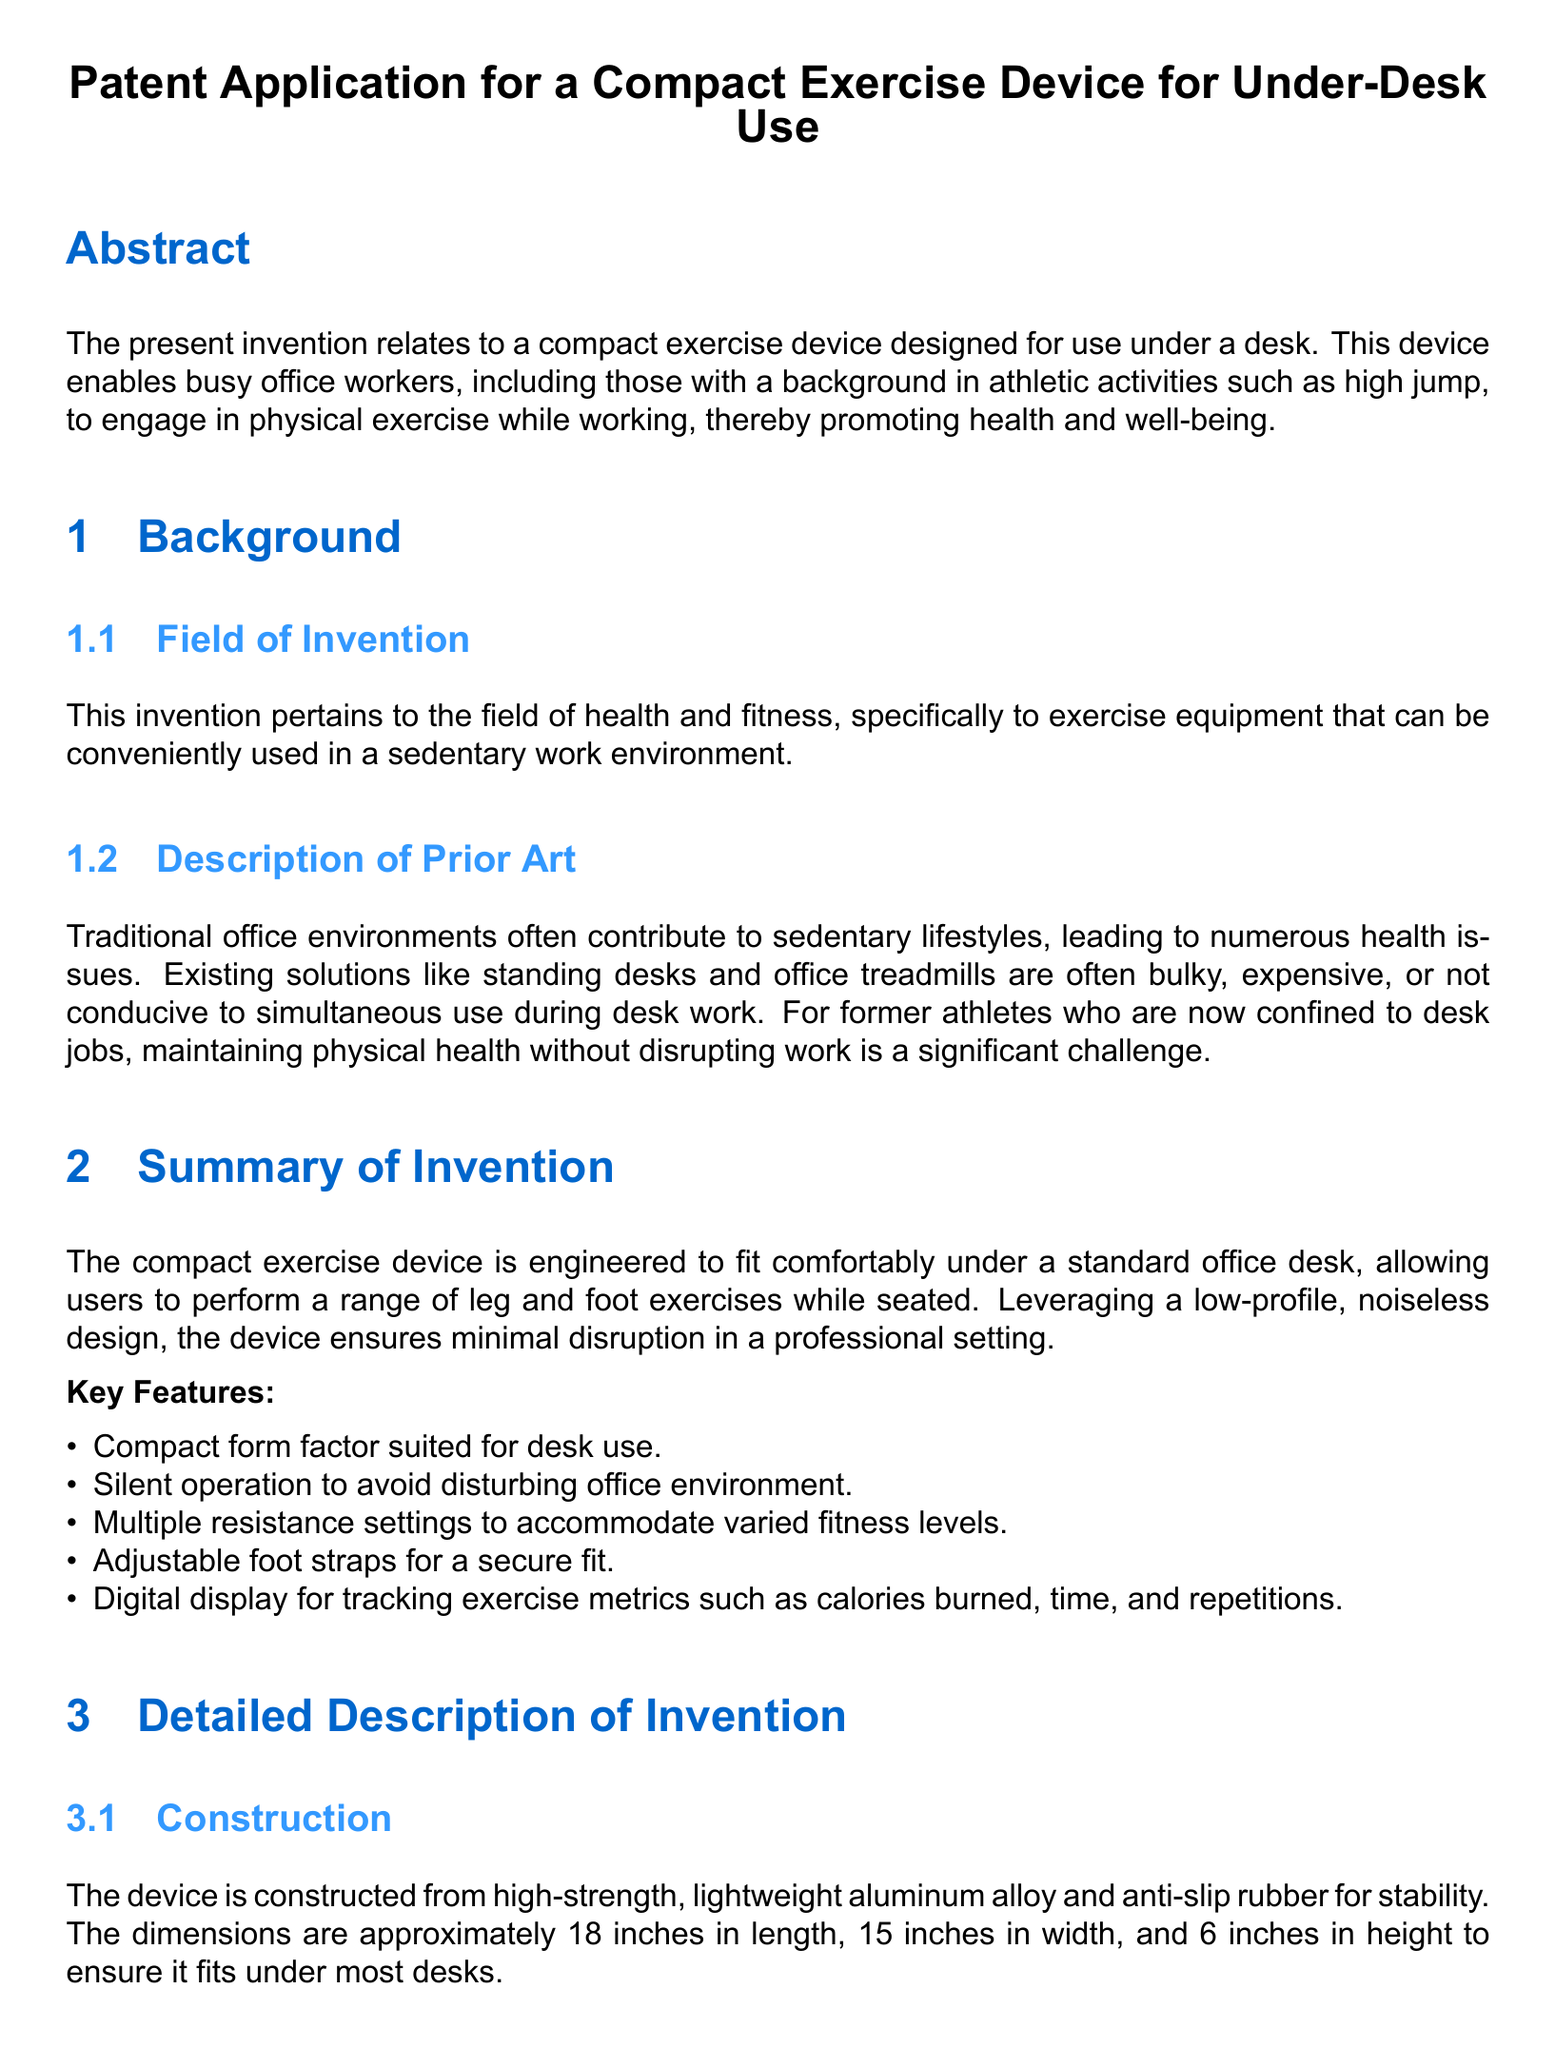What is the subject of the patent application? The patent application focuses on a device for exercise use while working at a desk.
Answer: Compact Exercise Device for Under-Desk Use What material is the device constructed from? The document specifies the material used for construction is high-strength, lightweight aluminum alloy and anti-slip rubber.
Answer: Aluminum alloy and anti-slip rubber What is the dimension of the device in height? The height of the device is specifically mentioned in the document.
Answer: 6 inches How many resistance settings does the device have? The document contains information about resistance settings available in the device, which is a feature for user adaptation.
Answer: Multiple resistance settings What is displayed on the digital screen of the device? The document notes the information tracked by the digital display, including various metrics.
Answer: Calories burned, time, and repetitions What type of resistance does the device utilize? The document describes the mechanism used for resistance in the exercise device.
Answer: Magnetic resistance What is the target user group for this device? The document outlines the target demographic benefiting from this invention, which includes athletes and professionals.
Answer: Busy office workers, former athletes How is the device's operation controlled? The document indicates how users can adjust the intensity of the device during operation.
Answer: A dial located on the side of the device What is the purpose of adjustable foot straps? The document explains part of the device’s design that enhances user comfort and fit.
Answer: To accommodate different foot sizes 